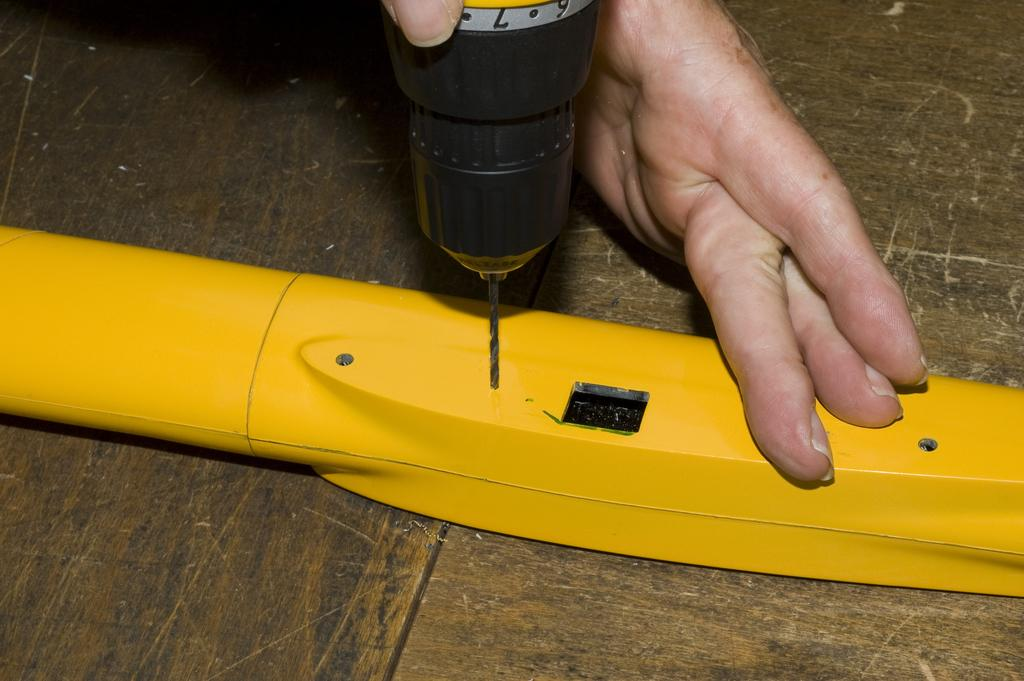What is the main subject of the image? There is a person in the image. What is the person holding in the image? The person is holding a drilling machine. Can you describe any other objects in the image? There is a yellow object on a wooden table in the image. What type of music can be heard playing in the background of the image? There is no music playing in the background of the image. What is the person about to start doing with the drilling machine in the image? The image does not show the person starting any action with the drilling machine, so it cannot be determined from the image. 